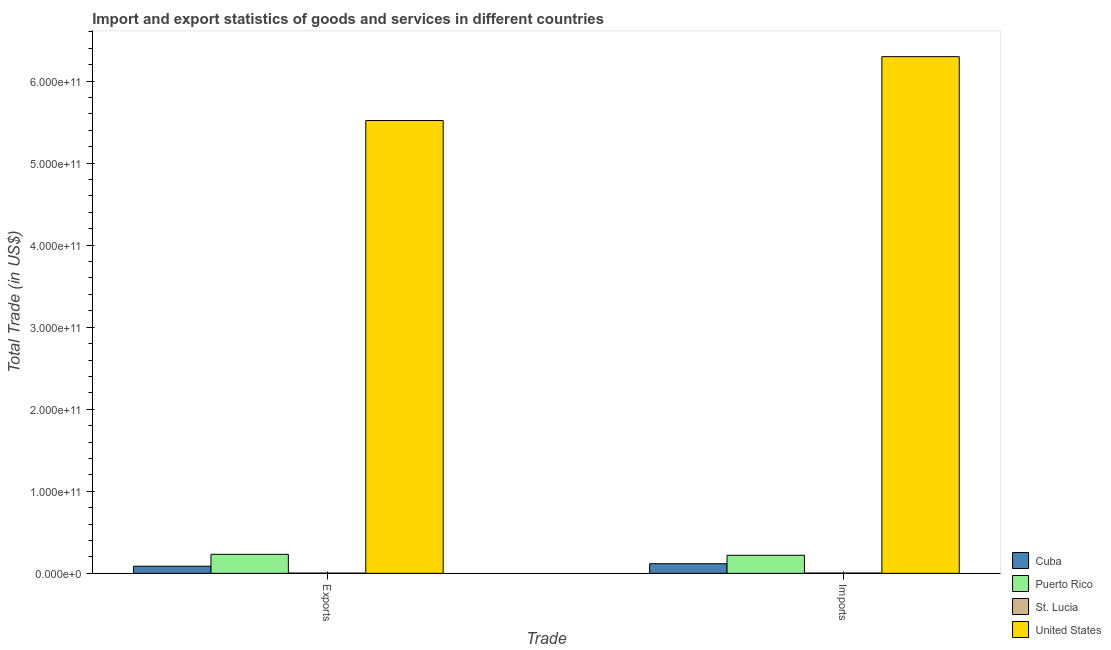Are the number of bars per tick equal to the number of legend labels?
Provide a short and direct response. Yes. Are the number of bars on each tick of the X-axis equal?
Provide a short and direct response. Yes. How many bars are there on the 1st tick from the right?
Keep it short and to the point. 4. What is the label of the 2nd group of bars from the left?
Ensure brevity in your answer.  Imports. What is the export of goods and services in United States?
Keep it short and to the point. 5.52e+11. Across all countries, what is the maximum export of goods and services?
Give a very brief answer. 5.52e+11. Across all countries, what is the minimum export of goods and services?
Ensure brevity in your answer.  2.88e+08. In which country was the imports of goods and services maximum?
Offer a very short reply. United States. In which country was the export of goods and services minimum?
Make the answer very short. St. Lucia. What is the total export of goods and services in the graph?
Offer a very short reply. 5.84e+11. What is the difference between the imports of goods and services in Cuba and that in United States?
Make the answer very short. -6.18e+11. What is the difference between the imports of goods and services in Cuba and the export of goods and services in St. Lucia?
Provide a short and direct response. 1.14e+1. What is the average imports of goods and services per country?
Your response must be concise. 1.66e+11. What is the difference between the export of goods and services and imports of goods and services in St. Lucia?
Provide a short and direct response. -4.61e+07. In how many countries, is the imports of goods and services greater than 200000000000 US$?
Your answer should be compact. 1. What is the ratio of the export of goods and services in United States to that in St. Lucia?
Provide a succinct answer. 1914.9. In how many countries, is the imports of goods and services greater than the average imports of goods and services taken over all countries?
Keep it short and to the point. 1. What does the 1st bar from the left in Imports represents?
Keep it short and to the point. Cuba. What does the 1st bar from the right in Imports represents?
Provide a succinct answer. United States. How many bars are there?
Your response must be concise. 8. How many countries are there in the graph?
Provide a succinct answer. 4. What is the difference between two consecutive major ticks on the Y-axis?
Your answer should be very brief. 1.00e+11. Does the graph contain any zero values?
Offer a very short reply. No. Does the graph contain grids?
Make the answer very short. No. How many legend labels are there?
Provide a succinct answer. 4. How are the legend labels stacked?
Your response must be concise. Vertical. What is the title of the graph?
Keep it short and to the point. Import and export statistics of goods and services in different countries. Does "Iceland" appear as one of the legend labels in the graph?
Offer a terse response. No. What is the label or title of the X-axis?
Your response must be concise. Trade. What is the label or title of the Y-axis?
Offer a very short reply. Total Trade (in US$). What is the Total Trade (in US$) of Cuba in Exports?
Your response must be concise. 8.66e+09. What is the Total Trade (in US$) of Puerto Rico in Exports?
Your response must be concise. 2.32e+1. What is the Total Trade (in US$) in St. Lucia in Exports?
Ensure brevity in your answer.  2.88e+08. What is the Total Trade (in US$) of United States in Exports?
Offer a very short reply. 5.52e+11. What is the Total Trade (in US$) in Cuba in Imports?
Your answer should be very brief. 1.17e+1. What is the Total Trade (in US$) of Puerto Rico in Imports?
Provide a succinct answer. 2.20e+1. What is the Total Trade (in US$) of St. Lucia in Imports?
Your answer should be very brief. 3.34e+08. What is the Total Trade (in US$) of United States in Imports?
Provide a short and direct response. 6.30e+11. Across all Trade, what is the maximum Total Trade (in US$) of Cuba?
Provide a short and direct response. 1.17e+1. Across all Trade, what is the maximum Total Trade (in US$) of Puerto Rico?
Give a very brief answer. 2.32e+1. Across all Trade, what is the maximum Total Trade (in US$) in St. Lucia?
Offer a terse response. 3.34e+08. Across all Trade, what is the maximum Total Trade (in US$) in United States?
Provide a succinct answer. 6.30e+11. Across all Trade, what is the minimum Total Trade (in US$) in Cuba?
Give a very brief answer. 8.66e+09. Across all Trade, what is the minimum Total Trade (in US$) in Puerto Rico?
Provide a succinct answer. 2.20e+1. Across all Trade, what is the minimum Total Trade (in US$) in St. Lucia?
Make the answer very short. 2.88e+08. Across all Trade, what is the minimum Total Trade (in US$) of United States?
Your answer should be compact. 5.52e+11. What is the total Total Trade (in US$) of Cuba in the graph?
Your answer should be compact. 2.04e+1. What is the total Total Trade (in US$) in Puerto Rico in the graph?
Your answer should be compact. 4.52e+1. What is the total Total Trade (in US$) of St. Lucia in the graph?
Provide a succinct answer. 6.22e+08. What is the total Total Trade (in US$) in United States in the graph?
Provide a short and direct response. 1.18e+12. What is the difference between the Total Trade (in US$) of Cuba in Exports and that in Imports?
Your answer should be very brief. -3.05e+09. What is the difference between the Total Trade (in US$) of Puerto Rico in Exports and that in Imports?
Your response must be concise. 1.16e+09. What is the difference between the Total Trade (in US$) of St. Lucia in Exports and that in Imports?
Ensure brevity in your answer.  -4.61e+07. What is the difference between the Total Trade (in US$) of United States in Exports and that in Imports?
Keep it short and to the point. -7.79e+1. What is the difference between the Total Trade (in US$) in Cuba in Exports and the Total Trade (in US$) in Puerto Rico in Imports?
Provide a succinct answer. -1.33e+1. What is the difference between the Total Trade (in US$) of Cuba in Exports and the Total Trade (in US$) of St. Lucia in Imports?
Make the answer very short. 8.33e+09. What is the difference between the Total Trade (in US$) in Cuba in Exports and the Total Trade (in US$) in United States in Imports?
Offer a terse response. -6.21e+11. What is the difference between the Total Trade (in US$) in Puerto Rico in Exports and the Total Trade (in US$) in St. Lucia in Imports?
Ensure brevity in your answer.  2.28e+1. What is the difference between the Total Trade (in US$) in Puerto Rico in Exports and the Total Trade (in US$) in United States in Imports?
Provide a short and direct response. -6.07e+11. What is the difference between the Total Trade (in US$) in St. Lucia in Exports and the Total Trade (in US$) in United States in Imports?
Your response must be concise. -6.29e+11. What is the average Total Trade (in US$) of Cuba per Trade?
Your answer should be very brief. 1.02e+1. What is the average Total Trade (in US$) of Puerto Rico per Trade?
Ensure brevity in your answer.  2.26e+1. What is the average Total Trade (in US$) of St. Lucia per Trade?
Your answer should be compact. 3.11e+08. What is the average Total Trade (in US$) of United States per Trade?
Make the answer very short. 5.91e+11. What is the difference between the Total Trade (in US$) in Cuba and Total Trade (in US$) in Puerto Rico in Exports?
Keep it short and to the point. -1.45e+1. What is the difference between the Total Trade (in US$) of Cuba and Total Trade (in US$) of St. Lucia in Exports?
Provide a succinct answer. 8.37e+09. What is the difference between the Total Trade (in US$) in Cuba and Total Trade (in US$) in United States in Exports?
Your response must be concise. -5.43e+11. What is the difference between the Total Trade (in US$) of Puerto Rico and Total Trade (in US$) of St. Lucia in Exports?
Offer a terse response. 2.29e+1. What is the difference between the Total Trade (in US$) in Puerto Rico and Total Trade (in US$) in United States in Exports?
Offer a terse response. -5.29e+11. What is the difference between the Total Trade (in US$) of St. Lucia and Total Trade (in US$) of United States in Exports?
Offer a terse response. -5.52e+11. What is the difference between the Total Trade (in US$) of Cuba and Total Trade (in US$) of Puerto Rico in Imports?
Ensure brevity in your answer.  -1.03e+1. What is the difference between the Total Trade (in US$) of Cuba and Total Trade (in US$) of St. Lucia in Imports?
Your answer should be very brief. 1.14e+1. What is the difference between the Total Trade (in US$) in Cuba and Total Trade (in US$) in United States in Imports?
Provide a short and direct response. -6.18e+11. What is the difference between the Total Trade (in US$) of Puerto Rico and Total Trade (in US$) of St. Lucia in Imports?
Make the answer very short. 2.17e+1. What is the difference between the Total Trade (in US$) in Puerto Rico and Total Trade (in US$) in United States in Imports?
Provide a short and direct response. -6.08e+11. What is the difference between the Total Trade (in US$) in St. Lucia and Total Trade (in US$) in United States in Imports?
Make the answer very short. -6.29e+11. What is the ratio of the Total Trade (in US$) in Cuba in Exports to that in Imports?
Your answer should be compact. 0.74. What is the ratio of the Total Trade (in US$) of Puerto Rico in Exports to that in Imports?
Give a very brief answer. 1.05. What is the ratio of the Total Trade (in US$) of St. Lucia in Exports to that in Imports?
Your answer should be compact. 0.86. What is the ratio of the Total Trade (in US$) of United States in Exports to that in Imports?
Keep it short and to the point. 0.88. What is the difference between the highest and the second highest Total Trade (in US$) in Cuba?
Your response must be concise. 3.05e+09. What is the difference between the highest and the second highest Total Trade (in US$) in Puerto Rico?
Keep it short and to the point. 1.16e+09. What is the difference between the highest and the second highest Total Trade (in US$) of St. Lucia?
Give a very brief answer. 4.61e+07. What is the difference between the highest and the second highest Total Trade (in US$) of United States?
Offer a very short reply. 7.79e+1. What is the difference between the highest and the lowest Total Trade (in US$) in Cuba?
Give a very brief answer. 3.05e+09. What is the difference between the highest and the lowest Total Trade (in US$) in Puerto Rico?
Ensure brevity in your answer.  1.16e+09. What is the difference between the highest and the lowest Total Trade (in US$) of St. Lucia?
Give a very brief answer. 4.61e+07. What is the difference between the highest and the lowest Total Trade (in US$) of United States?
Keep it short and to the point. 7.79e+1. 